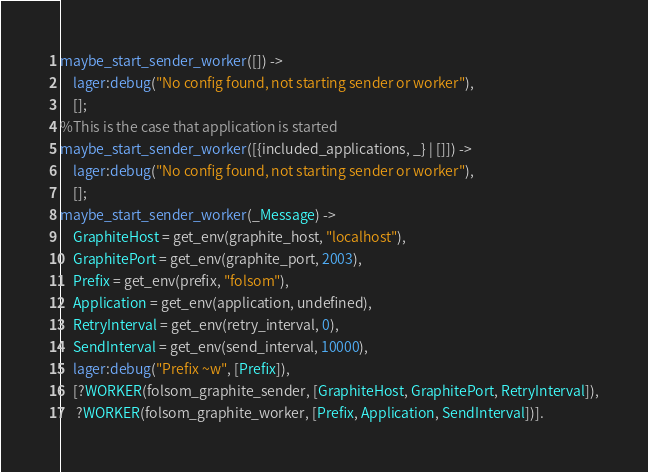Convert code to text. <code><loc_0><loc_0><loc_500><loc_500><_Erlang_>maybe_start_sender_worker([]) ->
    lager:debug("No config found, not starting sender or worker"),
    [];
%This is the case that application is started
maybe_start_sender_worker([{included_applications, _} | []]) ->
    lager:debug("No config found, not starting sender or worker"),
    [];
maybe_start_sender_worker(_Message) ->
    GraphiteHost = get_env(graphite_host, "localhost"),
    GraphitePort = get_env(graphite_port, 2003),
    Prefix = get_env(prefix, "folsom"),
    Application = get_env(application, undefined),
    RetryInterval = get_env(retry_interval, 0),
    SendInterval = get_env(send_interval, 10000),
    lager:debug("Prefix ~w", [Prefix]),
    [?WORKER(folsom_graphite_sender, [GraphiteHost, GraphitePort, RetryInterval]),
     ?WORKER(folsom_graphite_worker, [Prefix, Application, SendInterval])].
</code> 